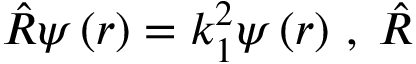Convert formula to latex. <formula><loc_0><loc_0><loc_500><loc_500>\hat { R } \psi \left ( r \right ) = k _ { 1 } ^ { 2 } \psi \left ( r \right ) \, , \, \hat { R }</formula> 